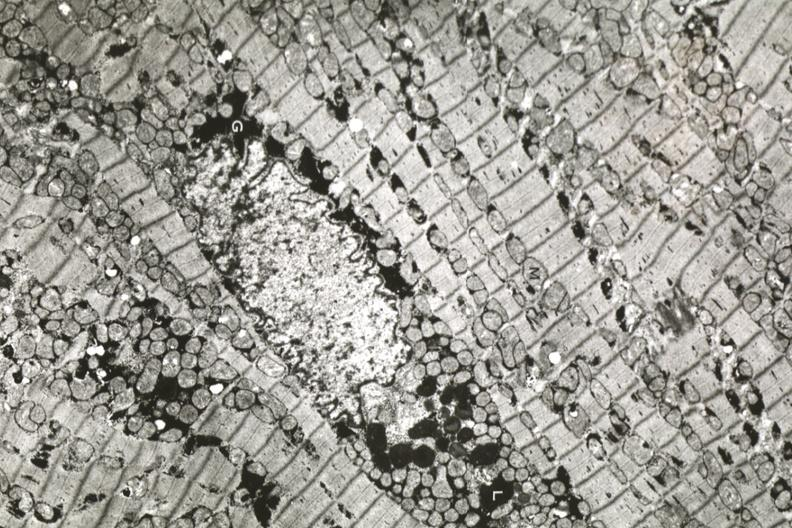s cardiovascular present?
Answer the question using a single word or phrase. Yes 